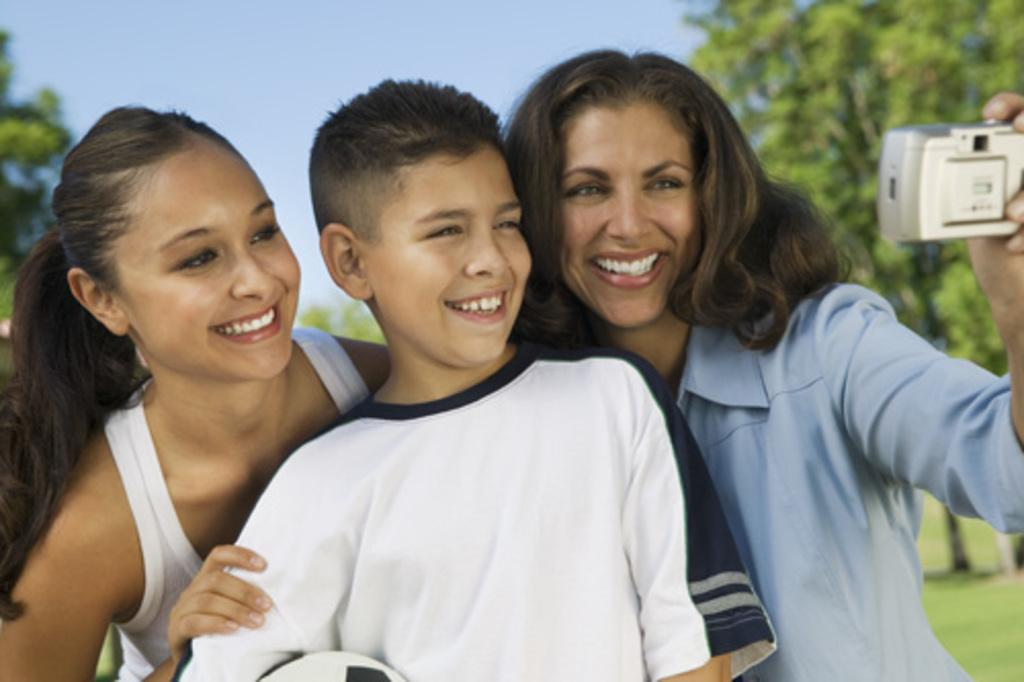How many people are in the image? There are three persons standing in the image. What are the expressions on their faces? The persons are smiling. What is one of the persons holding? One of the persons is holding a camera. What can be seen in the background of the image? There are trees and the sky visible in the background of the image. What type of bells can be heard ringing in the image? There are no bells or sounds present in the image, as it is a still photograph. Is there a self-portrait of the persons in the image? There is no indication in the image that the persons are taking a self-portrait, as one of them is holding a camera but not necessarily using it for that purpose. 